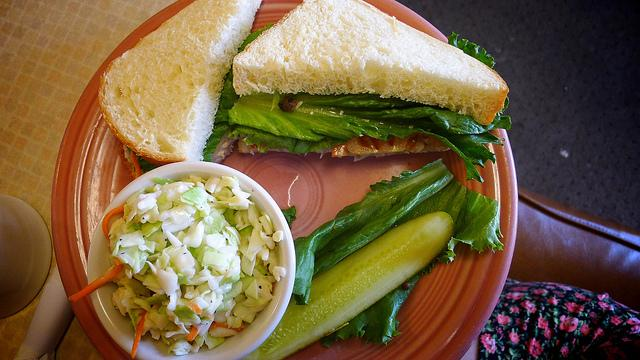From which vegetable is the main side dish sourced from mainly?

Choices:
A) lettuce
B) cabbage
C) apples
D) pears cabbage 